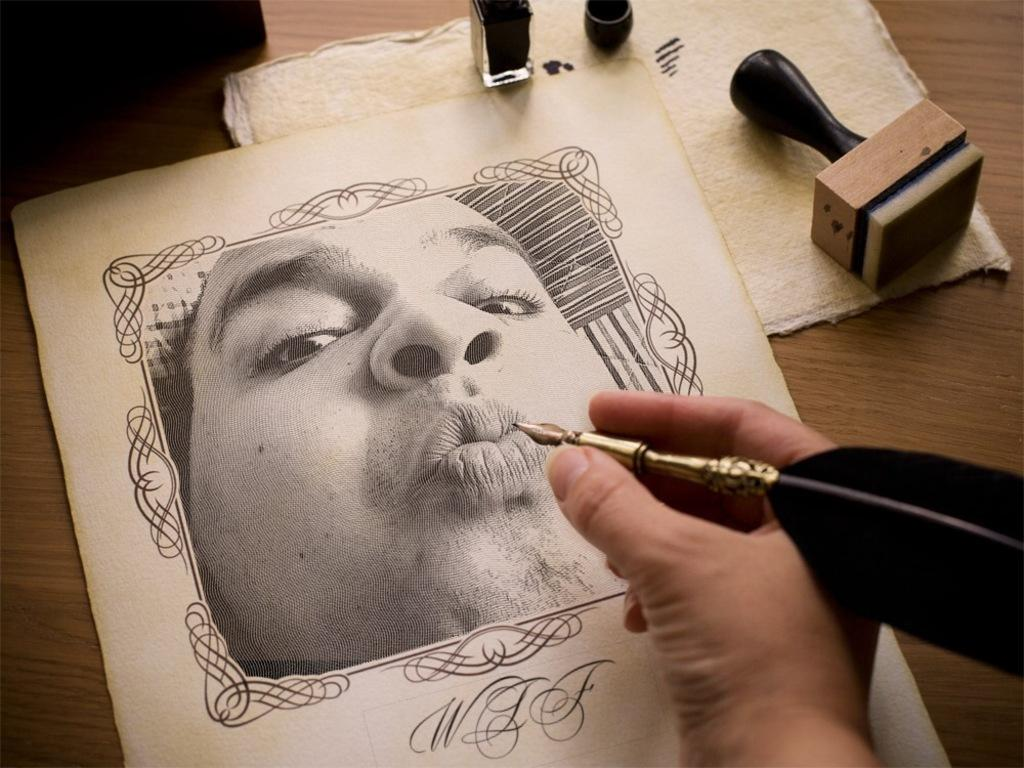What is the person's hand holding in the image? The person's hand is holding a pen in the image. What is the pen interacting with in the image? The pen is interacting with a paper in the image. What is depicted on the paper? The paper has an image of a person on it. What object is used for marking or stamping in the image? There is a rubber stamp in the image. What type of surface can be seen in the image? There are other objects on a wooden surface in the image. How many maids are present in the image? There are no maids present in the image. What type of girl is depicted on the paper? There is no girl depicted on the paper; it has an image of a person, but the gender is not specified. 